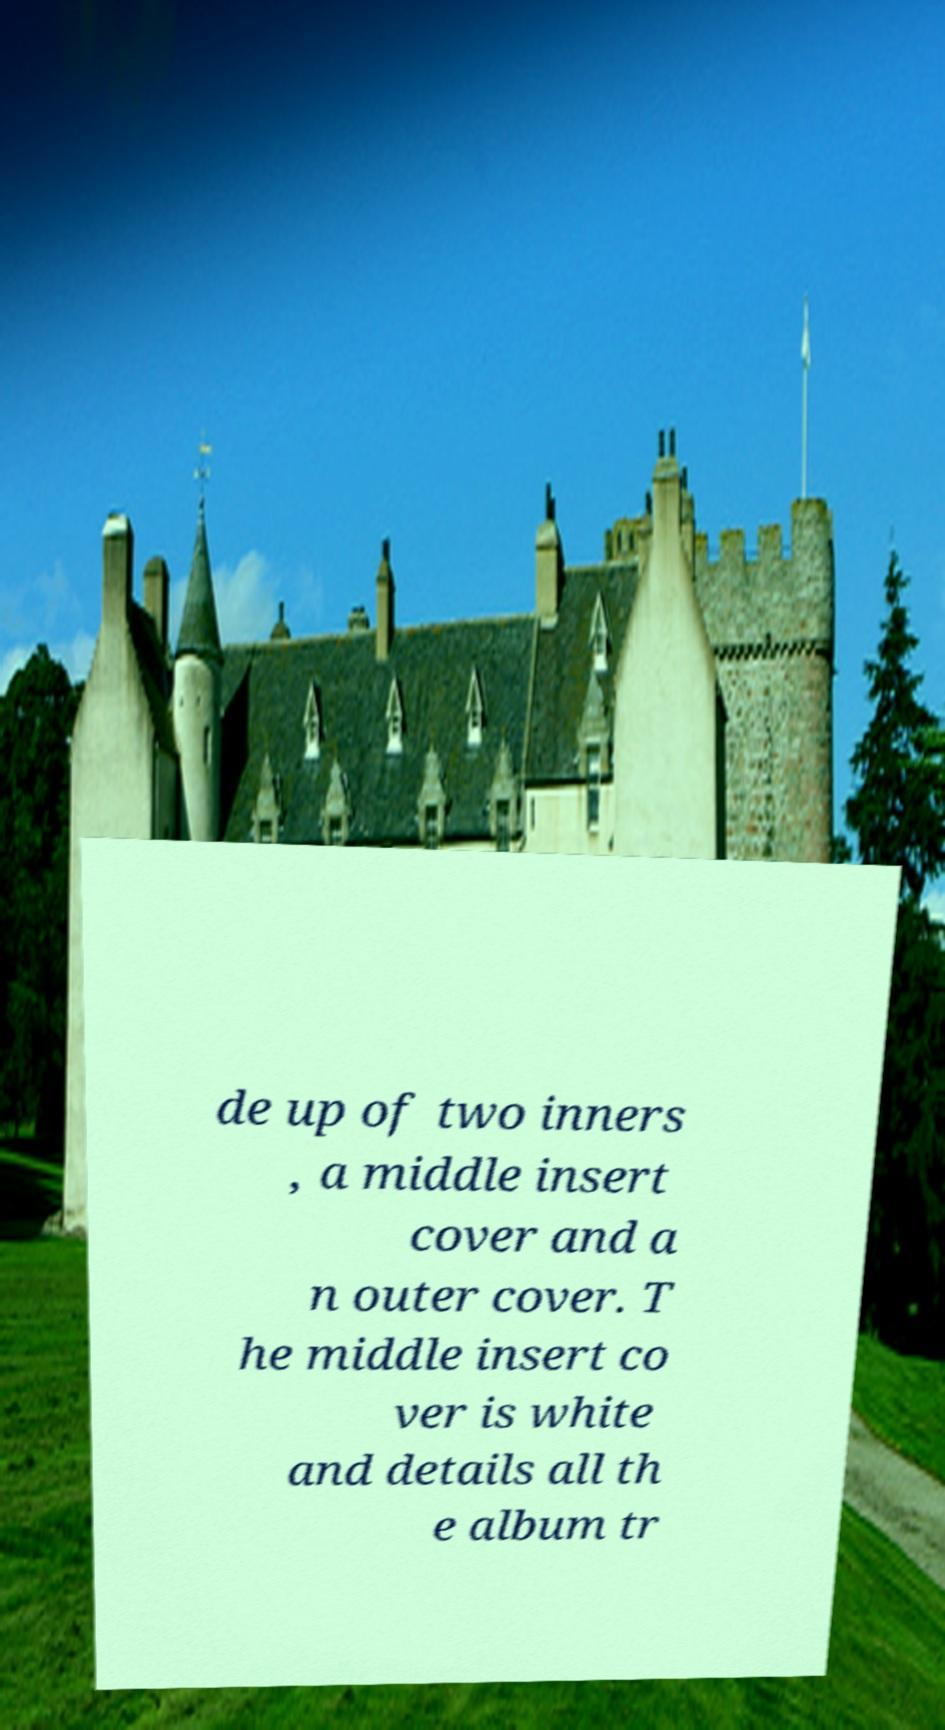I need the written content from this picture converted into text. Can you do that? de up of two inners , a middle insert cover and a n outer cover. T he middle insert co ver is white and details all th e album tr 